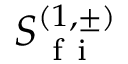Convert formula to latex. <formula><loc_0><loc_0><loc_500><loc_500>S _ { f i } ^ { ( 1 , \pm ) }</formula> 